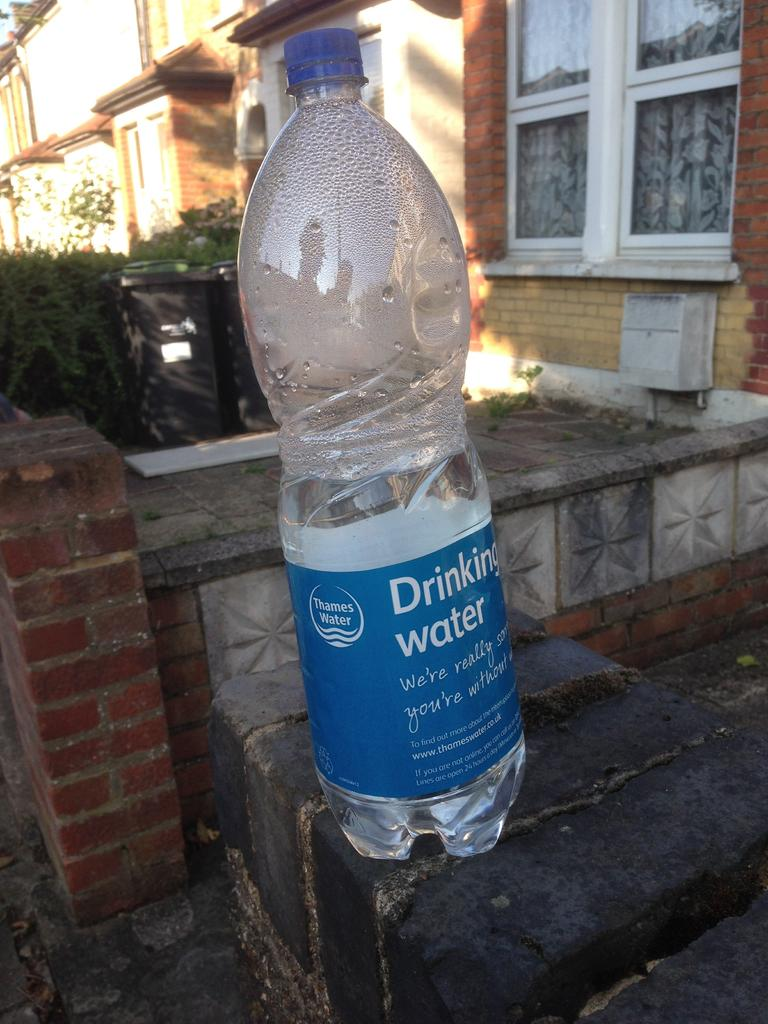What object is placed on the brick wall in the image? There is a bottle on a brick wall in the image. What can be seen behind the brick wall? There is a building visible behind the wall. What type of vegetation is visible behind the wall? There are plants visible behind the wall. How many crows are sitting on the bottle in the image? There are no crows present in the image. What type of prison is visible behind the wall in the image? There is no prison visible in the image; it features a bottle on a brick wall with a building and plants behind it. 